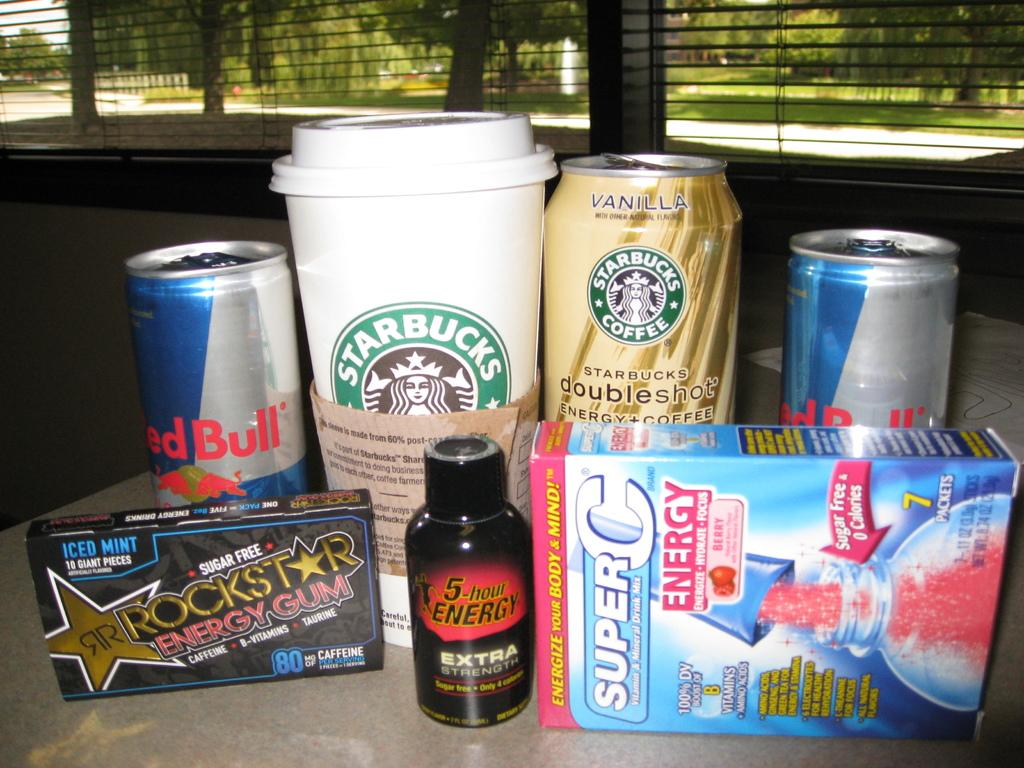Provide a one-sentence caption for the provided image. Starbucks cup and can, rockstar gum, super c energy, and red bull cans. 